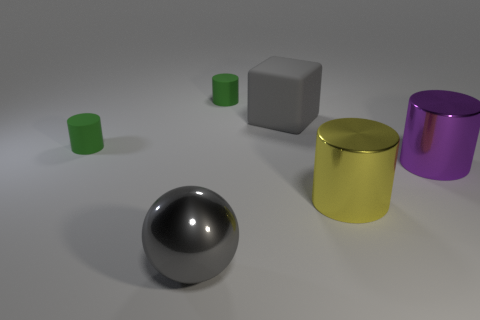How many large metallic objects are in front of the big gray object that is behind the big metal cylinder that is in front of the big purple shiny thing?
Ensure brevity in your answer.  3. There is a purple thing that is the same shape as the big yellow shiny thing; what is its size?
Provide a short and direct response. Large. Is the yellow cylinder right of the big gray sphere made of the same material as the purple cylinder?
Your answer should be compact. Yes. What is the color of the other big metal object that is the same shape as the yellow thing?
Give a very brief answer. Purple. What number of other things are there of the same color as the matte block?
Your answer should be very brief. 1. Does the small green rubber object behind the rubber cube have the same shape as the large shiny thing behind the large yellow shiny object?
Ensure brevity in your answer.  Yes. How many cubes are gray shiny things or large metallic objects?
Your response must be concise. 0. Are there fewer big purple metal objects on the left side of the purple cylinder than large purple shiny objects?
Ensure brevity in your answer.  Yes. What number of other objects are the same material as the gray cube?
Ensure brevity in your answer.  2. Is the size of the sphere the same as the purple metal thing?
Keep it short and to the point. Yes. 